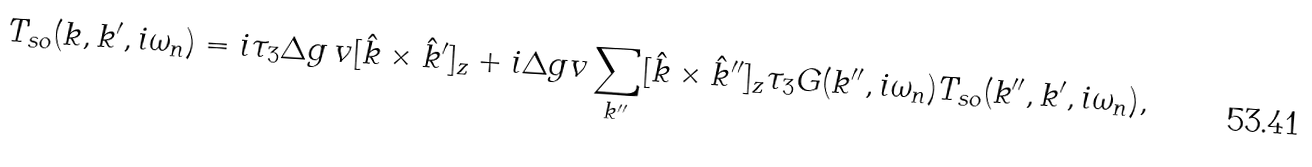<formula> <loc_0><loc_0><loc_500><loc_500>T _ { s o } ( { k } , { k } ^ { \prime } , i \omega _ { n } ) = i \tau _ { 3 } \Delta g \, v [ { \hat { k } } \times { \hat { k } } ^ { \prime } ] _ { z } + i \Delta g v \sum _ { { k } ^ { \prime \prime } } [ { \hat { k } } \times { \hat { k } } ^ { \prime \prime } ] _ { z } \tau _ { 3 } G ( { k } ^ { \prime \prime } , i \omega _ { n } ) T _ { s o } ( { k } ^ { \prime \prime } , { k } ^ { \prime } , i \omega _ { n } ) ,</formula> 